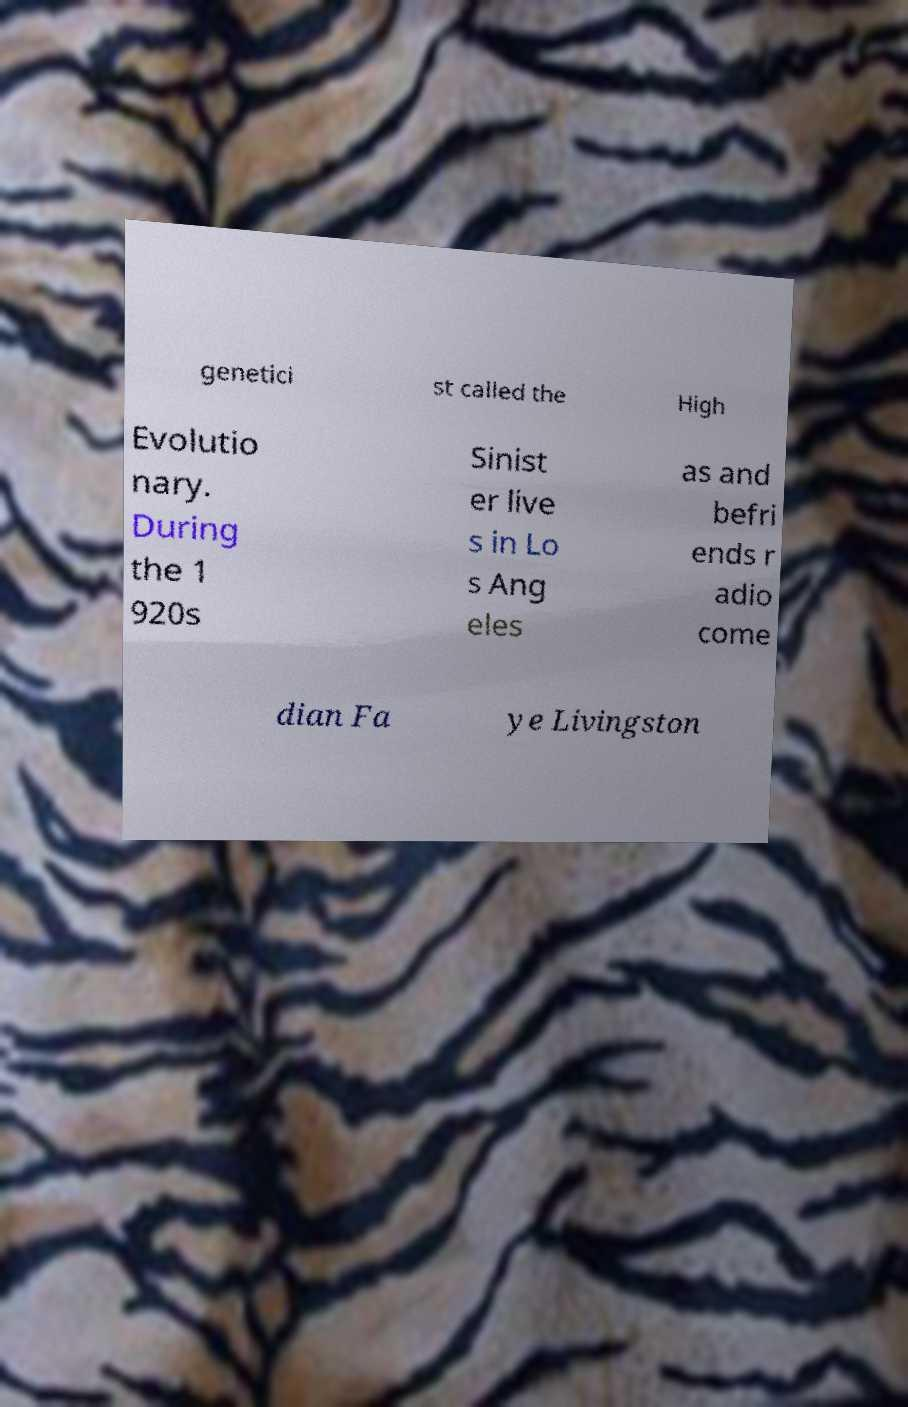Can you read and provide the text displayed in the image?This photo seems to have some interesting text. Can you extract and type it out for me? genetici st called the High Evolutio nary. During the 1 920s Sinist er live s in Lo s Ang eles as and befri ends r adio come dian Fa ye Livingston 